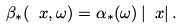Convert formula to latex. <formula><loc_0><loc_0><loc_500><loc_500>\beta _ { * } ( \ x , \omega ) = \alpha _ { * } ( \omega ) \, | \ x | \, .</formula> 